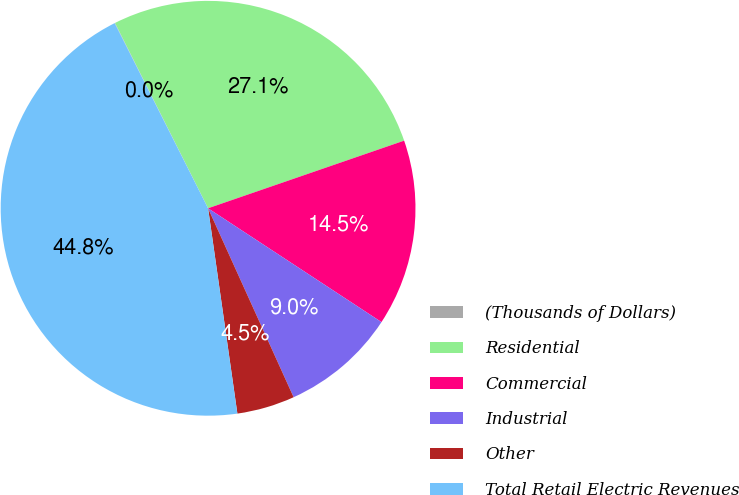Convert chart to OTSL. <chart><loc_0><loc_0><loc_500><loc_500><pie_chart><fcel>(Thousands of Dollars)<fcel>Residential<fcel>Commercial<fcel>Industrial<fcel>Other<fcel>Total Retail Electric Revenues<nl><fcel>0.03%<fcel>27.12%<fcel>14.53%<fcel>8.99%<fcel>4.51%<fcel>44.82%<nl></chart> 